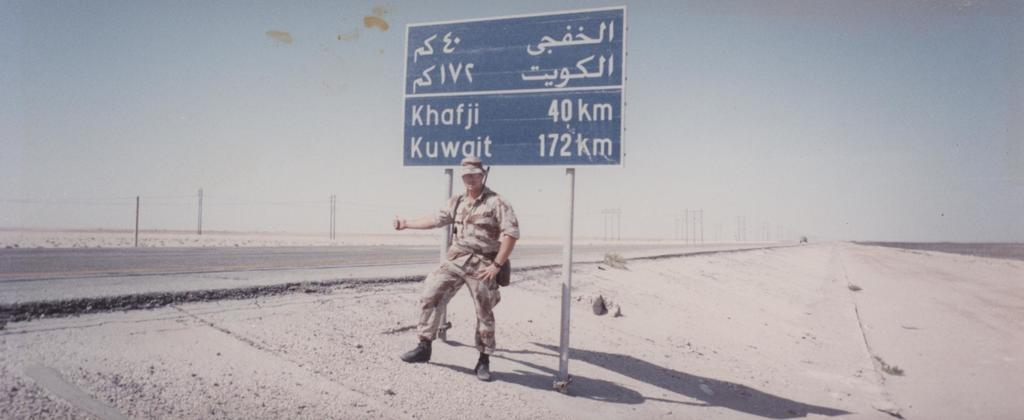<image>
Describe the image concisely. A soldier is in a hitchhiking position by a sign that shows Khafji at 40 kilometers away. 